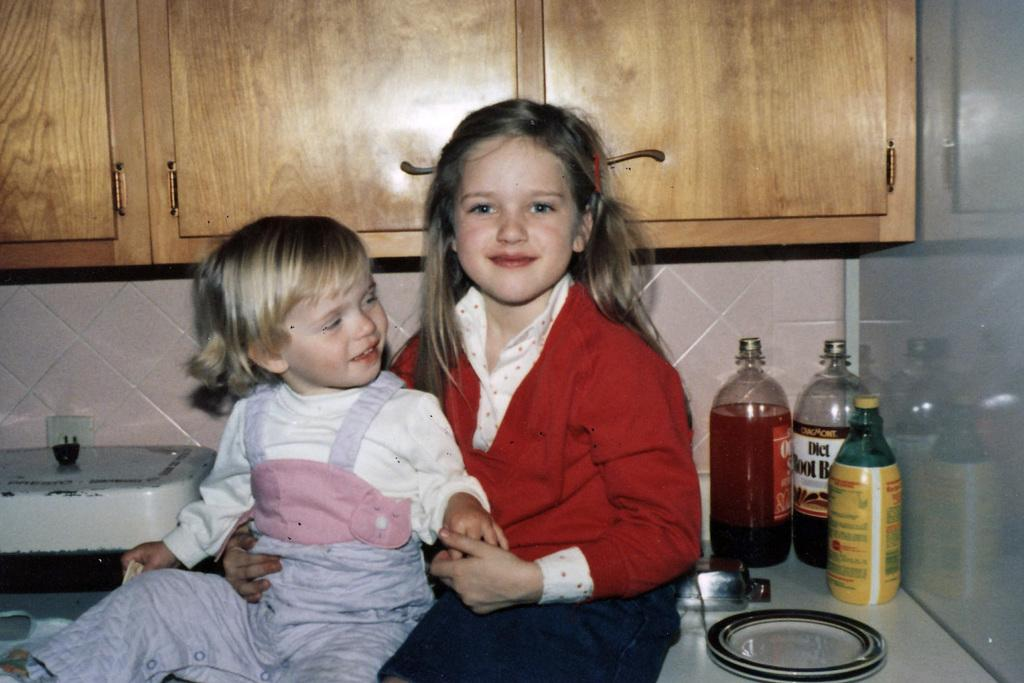Provide a one-sentence caption for the provided image. Two young girls sit on a counter near a bottle of diet root beer. 